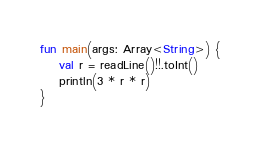<code> <loc_0><loc_0><loc_500><loc_500><_Kotlin_>fun main(args: Array<String>) {
    val r = readLine()!!.toInt()
    println(3 * r * r)
}</code> 